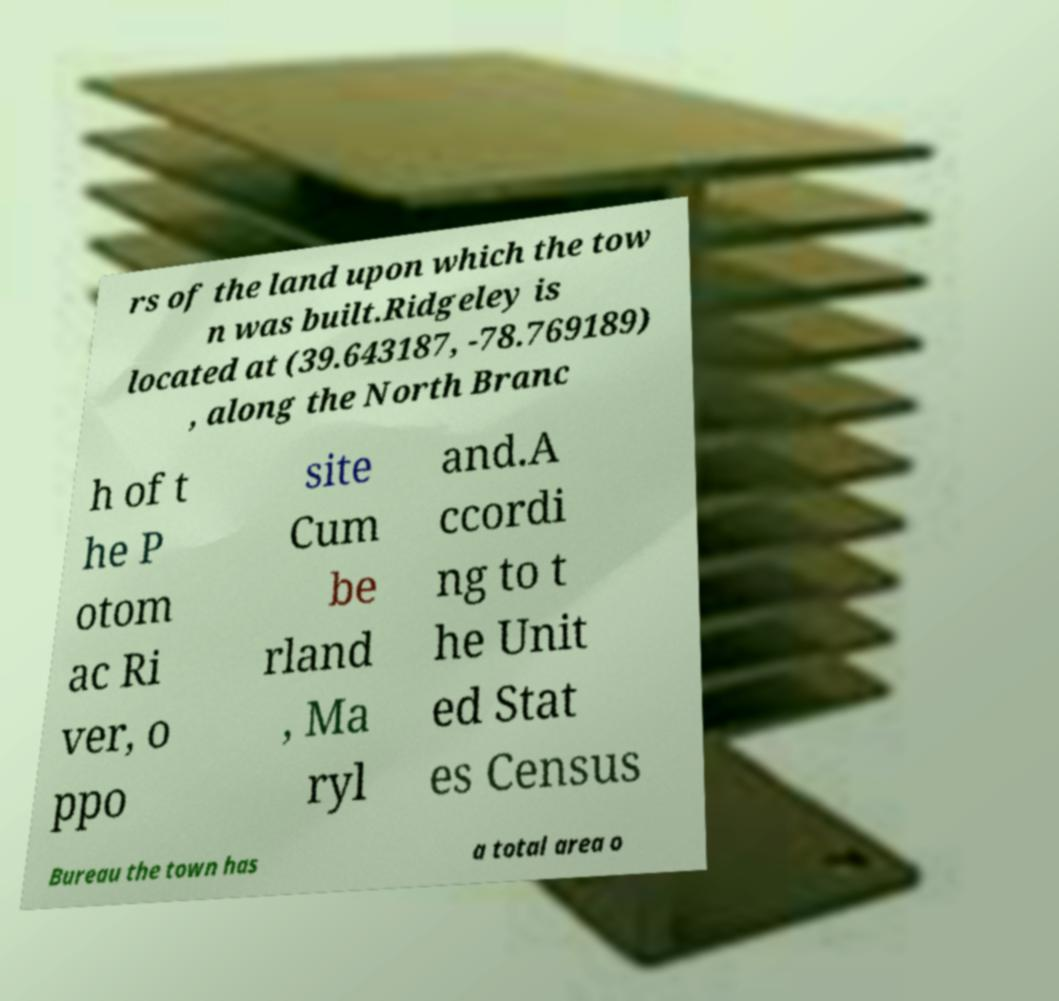Please read and relay the text visible in this image. What does it say? rs of the land upon which the tow n was built.Ridgeley is located at (39.643187, -78.769189) , along the North Branc h of t he P otom ac Ri ver, o ppo site Cum be rland , Ma ryl and.A ccordi ng to t he Unit ed Stat es Census Bureau the town has a total area o 